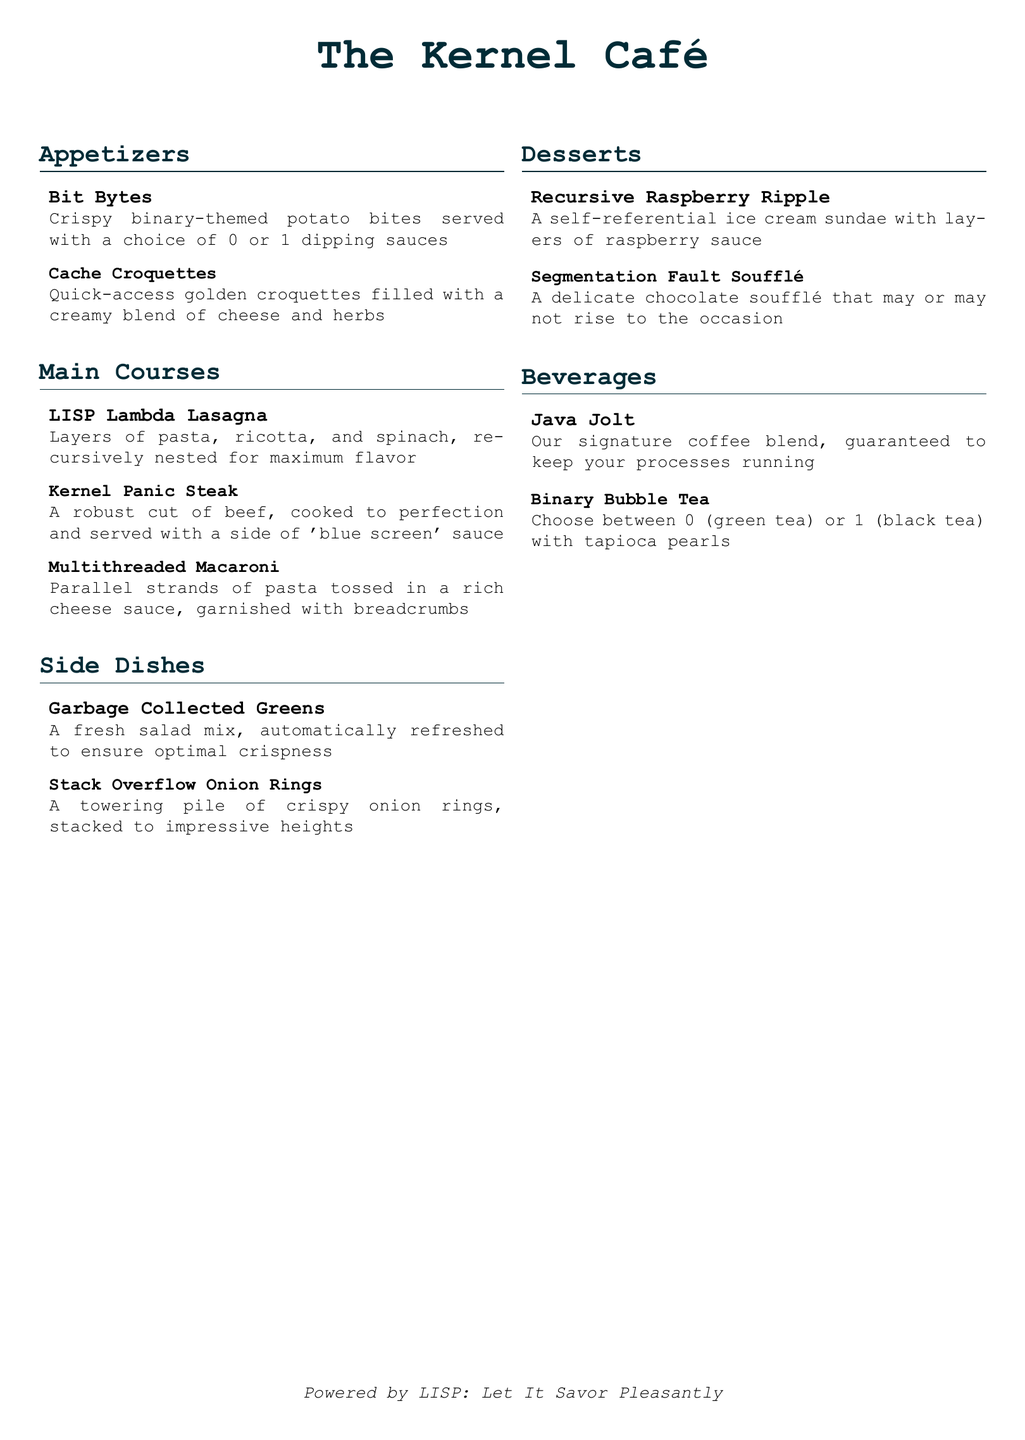What are the appetizers offered? The appetizers are listed under the "Appetizers" section of the menu, which includes "Bit Bytes" and "Cache Croquettes."
Answer: Bit Bytes, Cache Croquettes What type of main course is the Kernel Panic Steak? The Kernel Panic Steak is described as a robust cut of beef cooked to perfection with 'blue screen' sauce.
Answer: A robust cut of beef with 'blue screen' sauce How many desserts are listed on the menu? The menu includes a section for desserts, which has two items: "Recursive Raspberry Ripple" and "Segmentation Fault Soufflé."
Answer: Two What vegetable is in the Garbage Collected Greens salad? The Garbage Collected Greens refers to a fresh salad mix; however, the specific vegetable ingredients are not listed.
Answer: Fresh salad mix What is unique about the Recursive Raspberry Ripple dessert? The Recursive Raspberry Ripple is characterized as being self-referential, which indicates a unique preparation style.
Answer: Self-referential Which beverage option is associated with coffee? The beverage section lists "Java Jolt" as the signature coffee blend offered at the café.
Answer: Java Jolt What cooking technique is implied for the LISP Lambda Lasagna? The LISP Lambda Lasagna is described as being recursively nested, suggesting a technique of layering.
Answer: Recursively nested How are the Bit Bytes served? The Bit Bytes are crispy potato bites served with a choice of 0 or 1 dipping sauces.
Answer: With a choice of 0 or 1 dipping sauces What is the theme of the menu items? The theme is centered around programming concepts and operating system components, as reflected in the names of the dishes.
Answer: Programming concepts and operating system components 